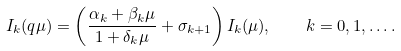<formula> <loc_0><loc_0><loc_500><loc_500>I _ { k } ( q \mu ) = \left ( \frac { \alpha _ { k } + \beta _ { k } \mu } { 1 + \delta _ { k } \mu } + \sigma _ { k + 1 } \right ) I _ { k } ( \mu ) , \quad k = 0 , 1 , \dots .</formula> 